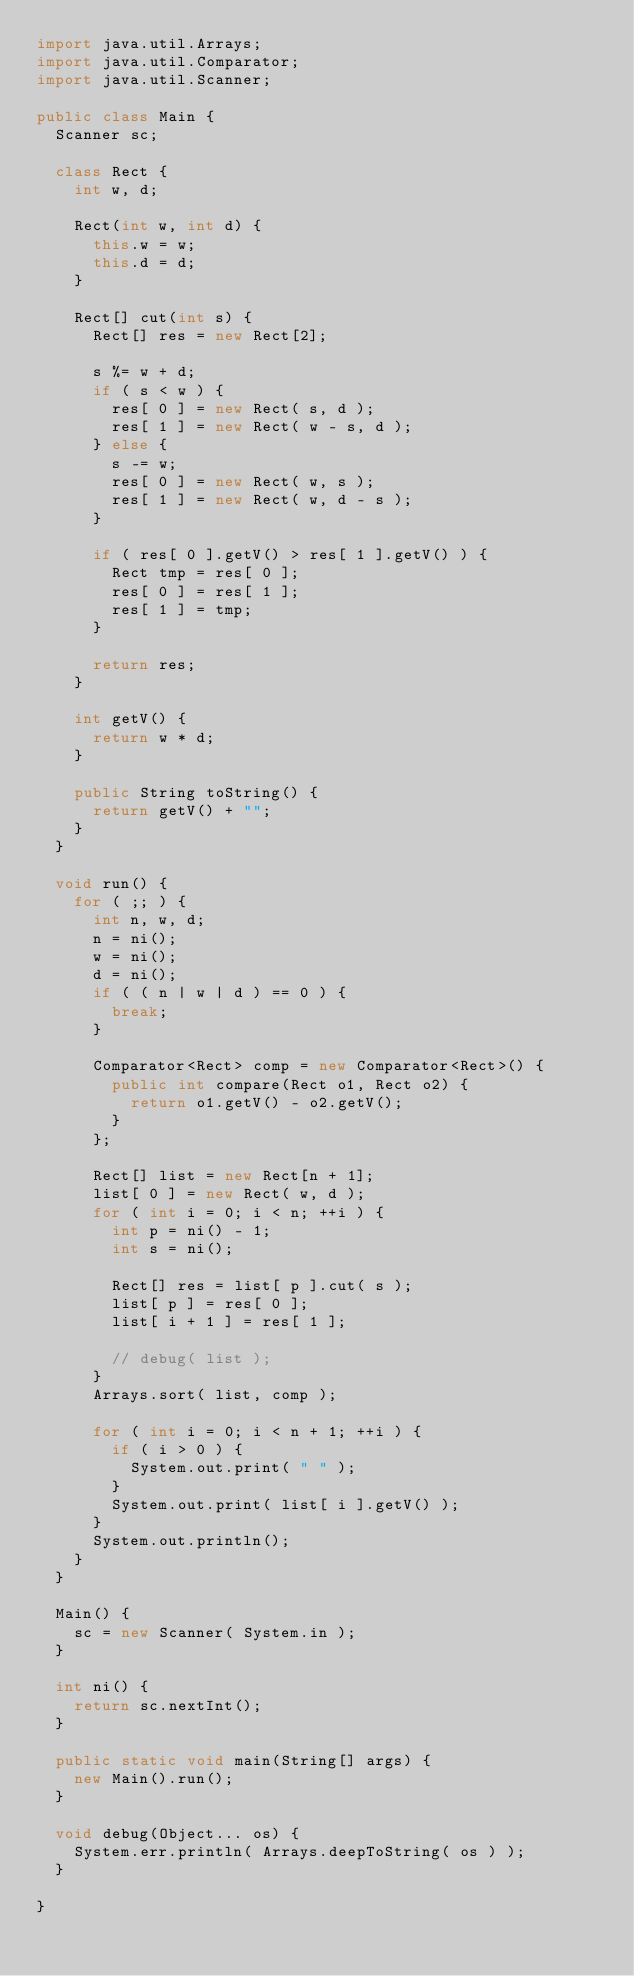<code> <loc_0><loc_0><loc_500><loc_500><_Java_>import java.util.Arrays;
import java.util.Comparator;
import java.util.Scanner;

public class Main {
  Scanner sc;

  class Rect {
    int w, d;

    Rect(int w, int d) {
      this.w = w;
      this.d = d;
    }

    Rect[] cut(int s) {
      Rect[] res = new Rect[2];

      s %= w + d;
      if ( s < w ) {
        res[ 0 ] = new Rect( s, d );
        res[ 1 ] = new Rect( w - s, d );
      } else {
        s -= w;
        res[ 0 ] = new Rect( w, s );
        res[ 1 ] = new Rect( w, d - s );
      }

      if ( res[ 0 ].getV() > res[ 1 ].getV() ) {
        Rect tmp = res[ 0 ];
        res[ 0 ] = res[ 1 ];
        res[ 1 ] = tmp;
      }

      return res;
    }

    int getV() {
      return w * d;
    }

    public String toString() {
      return getV() + "";
    }
  }

  void run() {
    for ( ;; ) {
      int n, w, d;
      n = ni();
      w = ni();
      d = ni();
      if ( ( n | w | d ) == 0 ) {
        break;
      }

      Comparator<Rect> comp = new Comparator<Rect>() {
        public int compare(Rect o1, Rect o2) {
          return o1.getV() - o2.getV();
        }
      };

      Rect[] list = new Rect[n + 1];
      list[ 0 ] = new Rect( w, d );
      for ( int i = 0; i < n; ++i ) {
        int p = ni() - 1;
        int s = ni();

        Rect[] res = list[ p ].cut( s );
        list[ p ] = res[ 0 ];
        list[ i + 1 ] = res[ 1 ];

        // debug( list );
      }
      Arrays.sort( list, comp );

      for ( int i = 0; i < n + 1; ++i ) {
        if ( i > 0 ) {
          System.out.print( " " );
        }
        System.out.print( list[ i ].getV() );
      }
      System.out.println();
    }
  }

  Main() {
    sc = new Scanner( System.in );
  }

  int ni() {
    return sc.nextInt();
  }

  public static void main(String[] args) {
    new Main().run();
  }

  void debug(Object... os) {
    System.err.println( Arrays.deepToString( os ) );
  }

}</code> 